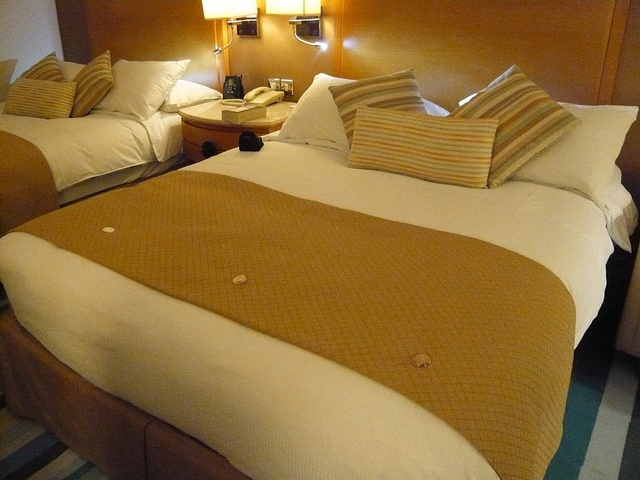Describe the objects in this image and their specific colors. I can see bed in olive, gray, and tan tones, bed in gray, maroon, olive, and tan tones, book in gray, olive, and tan tones, and clock in gray and black tones in this image. 